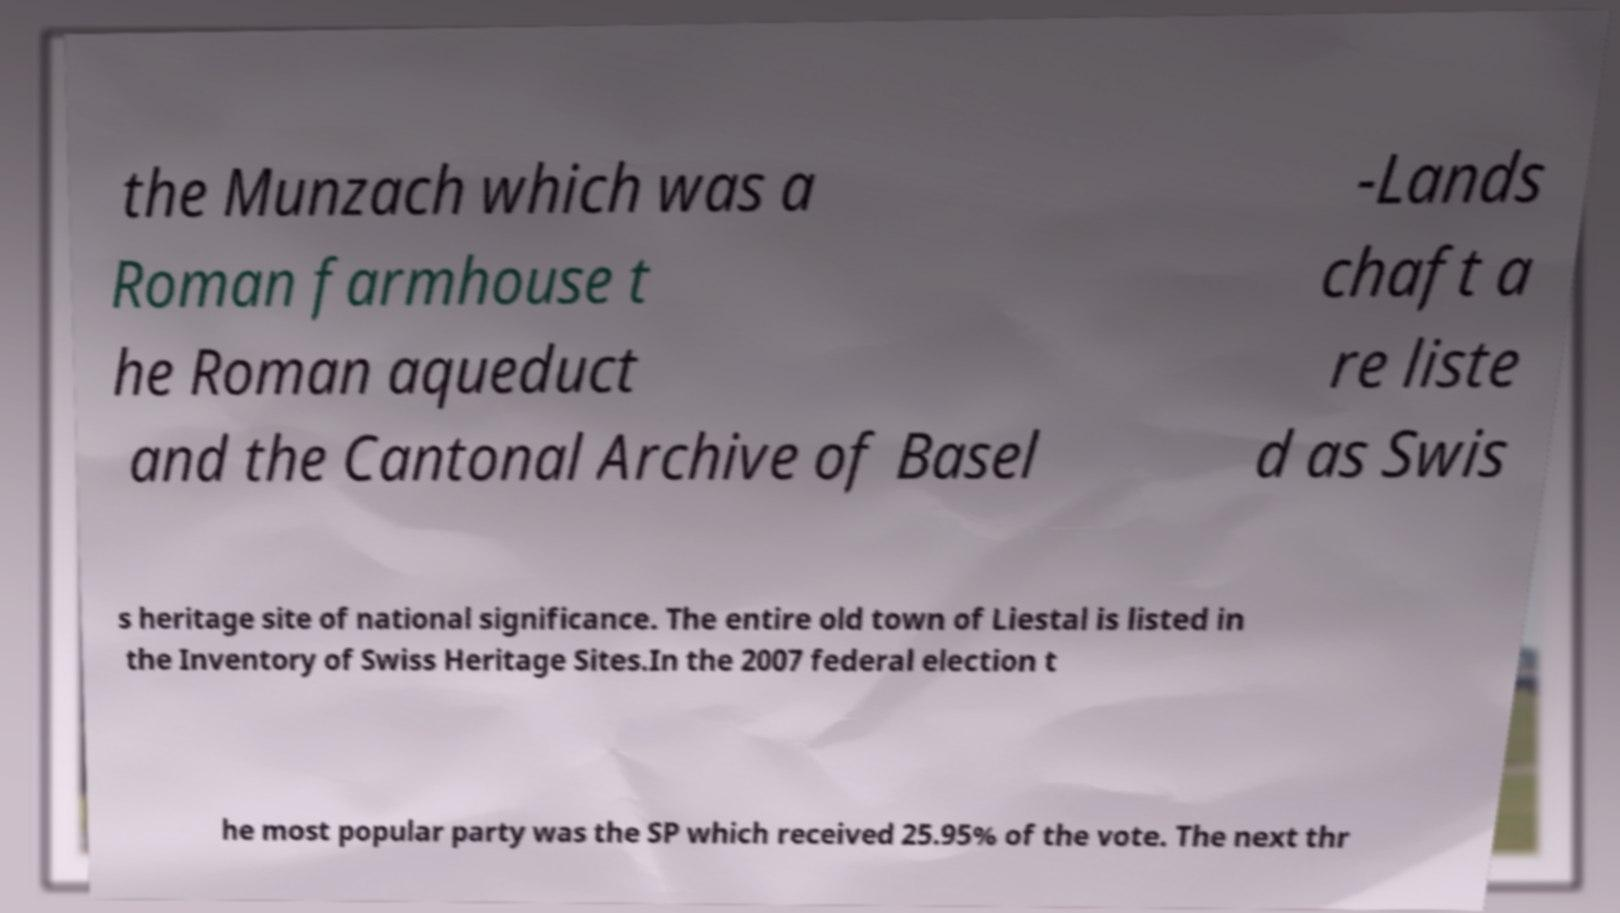I need the written content from this picture converted into text. Can you do that? the Munzach which was a Roman farmhouse t he Roman aqueduct and the Cantonal Archive of Basel -Lands chaft a re liste d as Swis s heritage site of national significance. The entire old town of Liestal is listed in the Inventory of Swiss Heritage Sites.In the 2007 federal election t he most popular party was the SP which received 25.95% of the vote. The next thr 